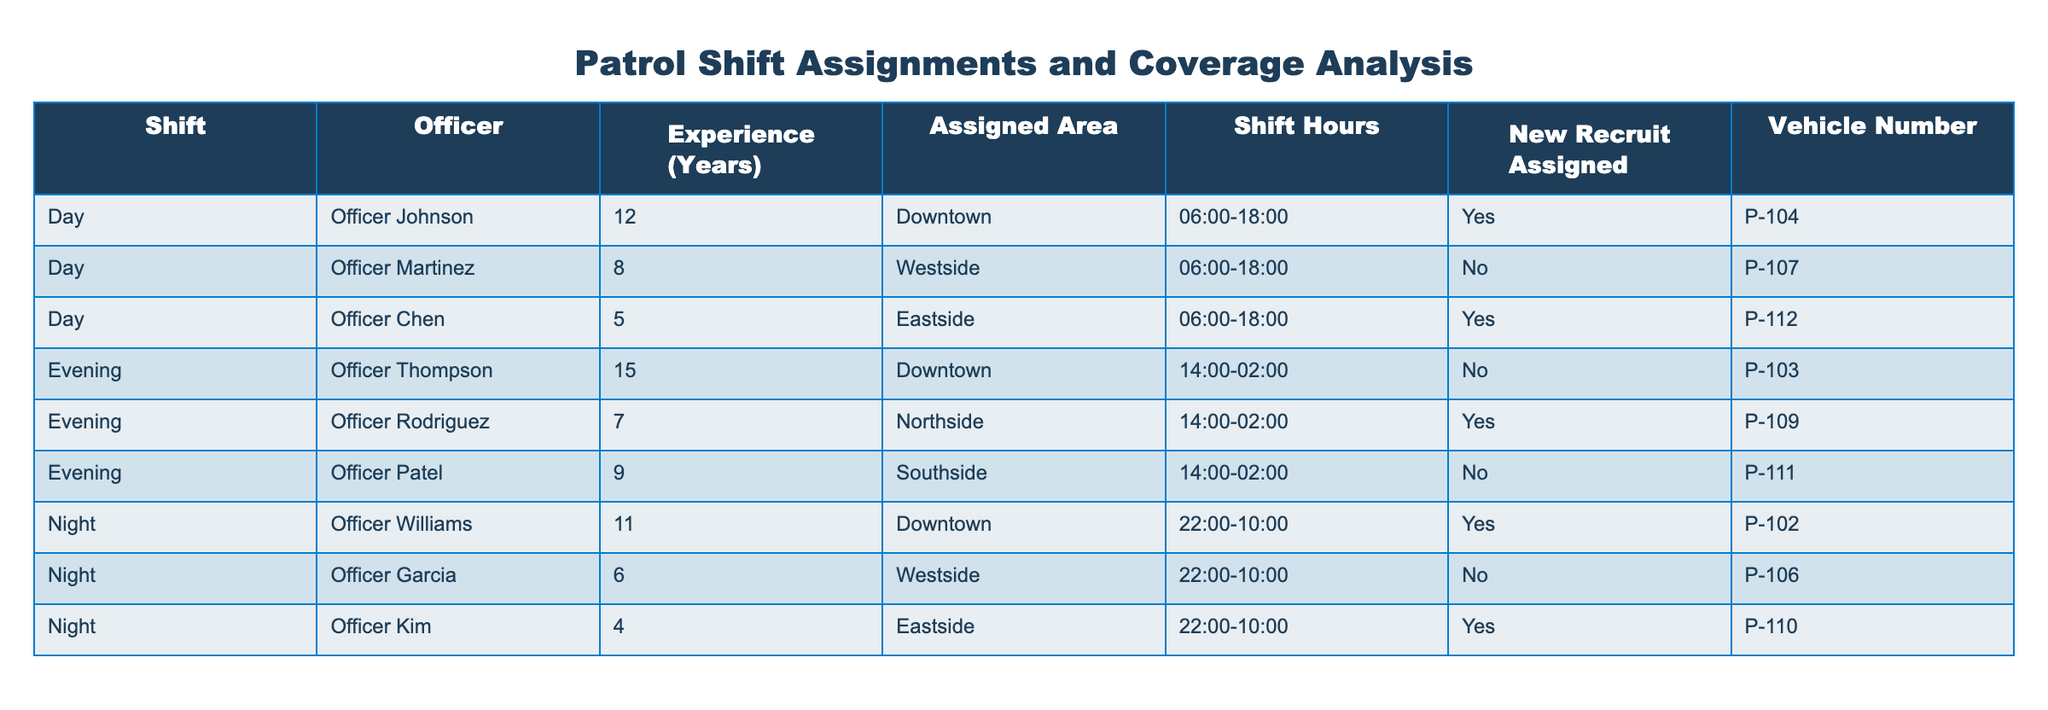What shift does Officer Chen work? Officer Chen is listed under the "Day" shift in the table.
Answer: Day How many officers are assigned to the Evening shift? The table shows three officers listed under the Evening shift: Officer Thompson, Officer Rodriguez, and Officer Patel.
Answer: 3 Is there a new recruit assigned to Officer Martinez? The table indicates that Officer Martinez is marked as "No" under the New Recruit Assigned column, meaning there is no new recruit assigned to him.
Answer: No What is the total experience in years of officers assigned to the Night shift? The officers in the Night shift are Officer Williams (11 years), Officer Garcia (6 years), and Officer Kim (4 years). Summing these gives a total experience of 11 + 6 + 4 = 21 years.
Answer: 21 Which officer is assigned to the Southside? Officer Patel is assigned to the Southside as indicated in the Assigned Area column of the table.
Answer: Officer Patel Are there any officers with more than 10 years of experience in Day shift assignments? The only Day shift officers are Officer Johnson (12 years) and Officer Martinez (8 years). Officer Johnson has more than 10 years of experience, so the answer is yes.
Answer: Yes List the vehicle numbers of officers assigned to the Eastside. The table shows that Officer Chen (P-112) and Officer Kim (P-110) are both assigned to the Eastside. Collectively, their vehicle numbers are P-112 and P-110.
Answer: P-112, P-110 What percentage of the officers assigned to the Day shift are new recruits? There are three officers assigned to the Day shift: Officer Johnson (Yes), Officer Martinez (No), and Officer Chen (Yes). This means 2 out of 3 are new recruits, giving a percentage of (2/3) * 100 = 66.67%.
Answer: 66.67% Which area has the highest assigned officers during the shift listed in the table? The Downtown area has the highest number of assigned officers, with Officer Johnson and Officer Thompson, totaling two officers assigned to that area.
Answer: Downtown 